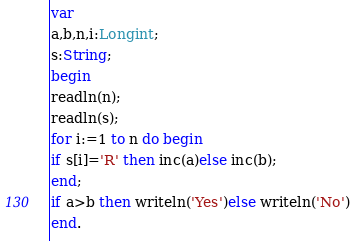Convert code to text. <code><loc_0><loc_0><loc_500><loc_500><_Pascal_>var
a,b,n,i:Longint;
s:String;
begin
readln(n);
readln(s);
for i:=1 to n do begin
if s[i]='R' then inc(a)else inc(b);
end;
if a>b then writeln('Yes')else writeln('No')
end.</code> 